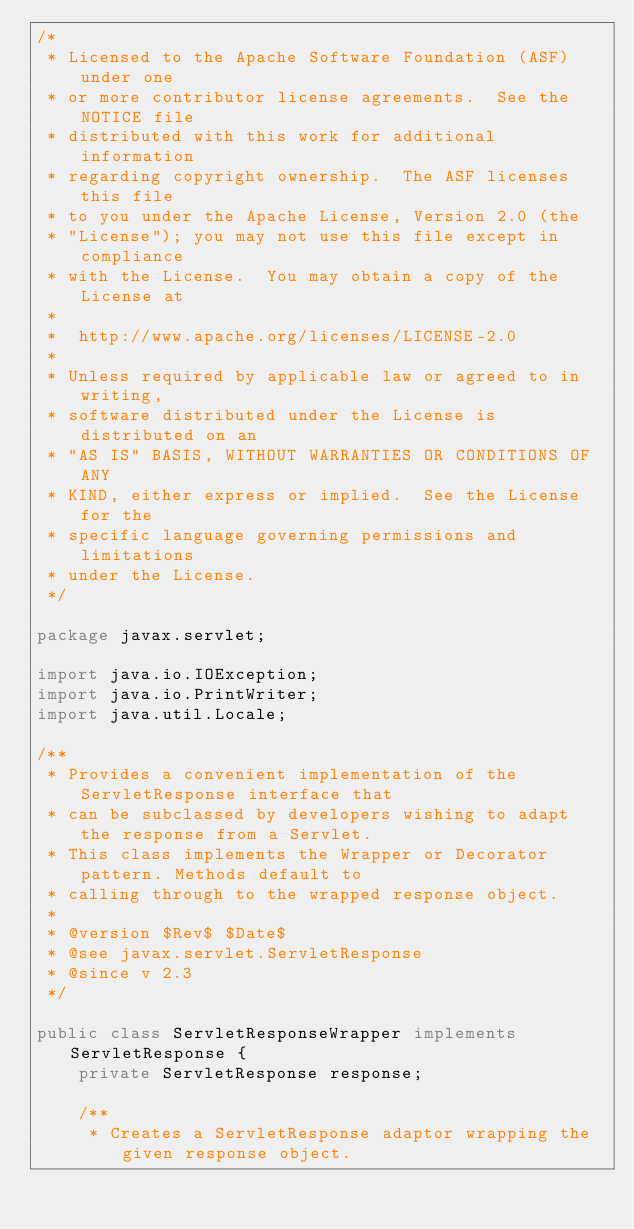Convert code to text. <code><loc_0><loc_0><loc_500><loc_500><_Java_>/*
 * Licensed to the Apache Software Foundation (ASF) under one
 * or more contributor license agreements.  See the NOTICE file
 * distributed with this work for additional information
 * regarding copyright ownership.  The ASF licenses this file
 * to you under the Apache License, Version 2.0 (the
 * "License"); you may not use this file except in compliance
 * with the License.  You may obtain a copy of the License at
 *
 *  http://www.apache.org/licenses/LICENSE-2.0
 *
 * Unless required by applicable law or agreed to in writing,
 * software distributed under the License is distributed on an
 * "AS IS" BASIS, WITHOUT WARRANTIES OR CONDITIONS OF ANY
 * KIND, either express or implied.  See the License for the
 * specific language governing permissions and limitations
 * under the License.
 */

package javax.servlet;

import java.io.IOException;
import java.io.PrintWriter;
import java.util.Locale;

/**
 * Provides a convenient implementation of the ServletResponse interface that
 * can be subclassed by developers wishing to adapt the response from a Servlet.
 * This class implements the Wrapper or Decorator pattern. Methods default to
 * calling through to the wrapped response object.
 *
 * @version $Rev$ $Date$
 * @see javax.servlet.ServletResponse
 * @since v 2.3
 */

public class ServletResponseWrapper implements ServletResponse {
    private ServletResponse response;

    /**
     * Creates a ServletResponse adaptor wrapping the given response object.</code> 